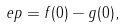Convert formula to latex. <formula><loc_0><loc_0><loc_500><loc_500>\ e p = f ( 0 ) - g ( 0 ) ,</formula> 